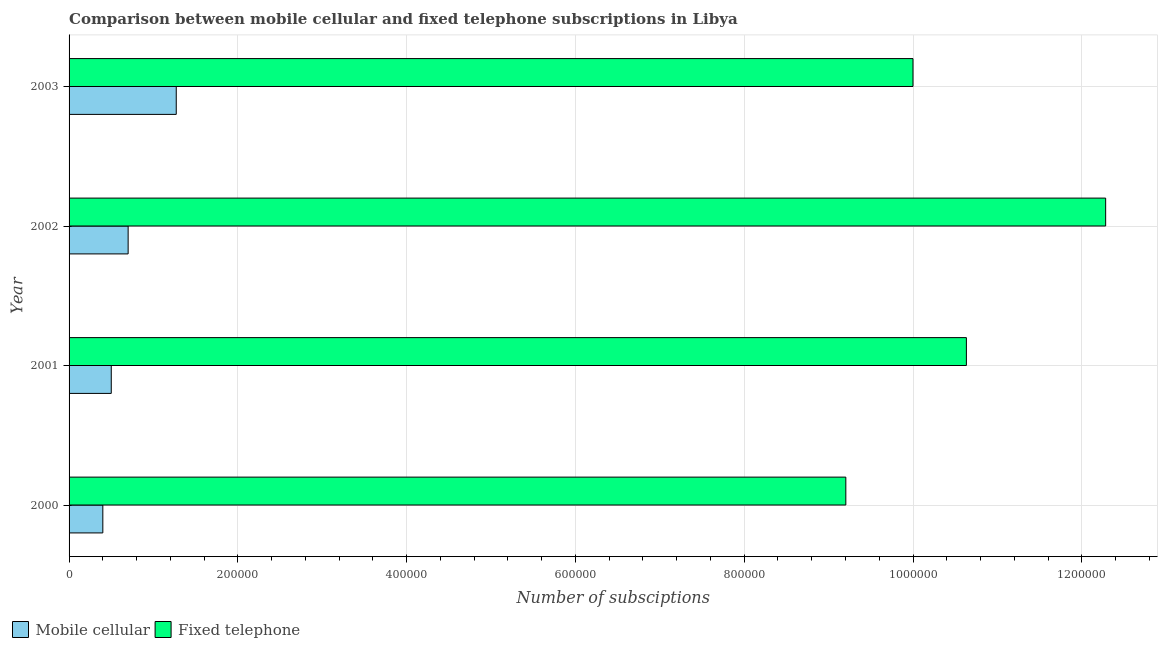How many groups of bars are there?
Keep it short and to the point. 4. Are the number of bars per tick equal to the number of legend labels?
Keep it short and to the point. Yes. In how many cases, is the number of bars for a given year not equal to the number of legend labels?
Offer a very short reply. 0. What is the number of fixed telephone subscriptions in 2001?
Offer a terse response. 1.06e+06. Across all years, what is the maximum number of mobile cellular subscriptions?
Make the answer very short. 1.27e+05. Across all years, what is the minimum number of mobile cellular subscriptions?
Offer a very short reply. 4.00e+04. In which year was the number of fixed telephone subscriptions minimum?
Make the answer very short. 2000. What is the total number of fixed telephone subscriptions in the graph?
Provide a succinct answer. 4.21e+06. What is the difference between the number of mobile cellular subscriptions in 2000 and that in 2001?
Provide a short and direct response. -10000. What is the difference between the number of mobile cellular subscriptions in 2002 and the number of fixed telephone subscriptions in 2003?
Your answer should be very brief. -9.30e+05. What is the average number of fixed telephone subscriptions per year?
Provide a short and direct response. 1.05e+06. In the year 2001, what is the difference between the number of fixed telephone subscriptions and number of mobile cellular subscriptions?
Your answer should be compact. 1.01e+06. What is the ratio of the number of mobile cellular subscriptions in 2000 to that in 2003?
Provide a succinct answer. 0.32. Is the number of mobile cellular subscriptions in 2000 less than that in 2001?
Your answer should be compact. Yes. What is the difference between the highest and the second highest number of mobile cellular subscriptions?
Your answer should be very brief. 5.70e+04. What is the difference between the highest and the lowest number of fixed telephone subscriptions?
Provide a succinct answer. 3.08e+05. What does the 2nd bar from the top in 2002 represents?
Ensure brevity in your answer.  Mobile cellular. What does the 2nd bar from the bottom in 2002 represents?
Give a very brief answer. Fixed telephone. How many bars are there?
Your response must be concise. 8. How many legend labels are there?
Provide a short and direct response. 2. How are the legend labels stacked?
Provide a succinct answer. Horizontal. What is the title of the graph?
Provide a succinct answer. Comparison between mobile cellular and fixed telephone subscriptions in Libya. Does "Working only" appear as one of the legend labels in the graph?
Make the answer very short. No. What is the label or title of the X-axis?
Your answer should be very brief. Number of subsciptions. What is the Number of subsciptions of Mobile cellular in 2000?
Offer a very short reply. 4.00e+04. What is the Number of subsciptions of Fixed telephone in 2000?
Offer a terse response. 9.20e+05. What is the Number of subsciptions in Fixed telephone in 2001?
Provide a short and direct response. 1.06e+06. What is the Number of subsciptions in Fixed telephone in 2002?
Your response must be concise. 1.23e+06. What is the Number of subsciptions in Mobile cellular in 2003?
Make the answer very short. 1.27e+05. Across all years, what is the maximum Number of subsciptions of Mobile cellular?
Give a very brief answer. 1.27e+05. Across all years, what is the maximum Number of subsciptions of Fixed telephone?
Keep it short and to the point. 1.23e+06. Across all years, what is the minimum Number of subsciptions of Mobile cellular?
Provide a succinct answer. 4.00e+04. Across all years, what is the minimum Number of subsciptions in Fixed telephone?
Ensure brevity in your answer.  9.20e+05. What is the total Number of subsciptions of Mobile cellular in the graph?
Your answer should be very brief. 2.87e+05. What is the total Number of subsciptions of Fixed telephone in the graph?
Give a very brief answer. 4.21e+06. What is the difference between the Number of subsciptions of Mobile cellular in 2000 and that in 2001?
Your response must be concise. -10000. What is the difference between the Number of subsciptions of Fixed telephone in 2000 and that in 2001?
Provide a short and direct response. -1.43e+05. What is the difference between the Number of subsciptions of Fixed telephone in 2000 and that in 2002?
Provide a short and direct response. -3.08e+05. What is the difference between the Number of subsciptions of Mobile cellular in 2000 and that in 2003?
Provide a succinct answer. -8.70e+04. What is the difference between the Number of subsciptions in Fixed telephone in 2000 and that in 2003?
Make the answer very short. -7.96e+04. What is the difference between the Number of subsciptions in Fixed telephone in 2001 and that in 2002?
Your answer should be very brief. -1.65e+05. What is the difference between the Number of subsciptions in Mobile cellular in 2001 and that in 2003?
Provide a short and direct response. -7.70e+04. What is the difference between the Number of subsciptions of Fixed telephone in 2001 and that in 2003?
Your response must be concise. 6.33e+04. What is the difference between the Number of subsciptions in Mobile cellular in 2002 and that in 2003?
Your answer should be very brief. -5.70e+04. What is the difference between the Number of subsciptions of Fixed telephone in 2002 and that in 2003?
Make the answer very short. 2.28e+05. What is the difference between the Number of subsciptions of Mobile cellular in 2000 and the Number of subsciptions of Fixed telephone in 2001?
Your answer should be very brief. -1.02e+06. What is the difference between the Number of subsciptions in Mobile cellular in 2000 and the Number of subsciptions in Fixed telephone in 2002?
Ensure brevity in your answer.  -1.19e+06. What is the difference between the Number of subsciptions in Mobile cellular in 2000 and the Number of subsciptions in Fixed telephone in 2003?
Offer a very short reply. -9.60e+05. What is the difference between the Number of subsciptions in Mobile cellular in 2001 and the Number of subsciptions in Fixed telephone in 2002?
Keep it short and to the point. -1.18e+06. What is the difference between the Number of subsciptions of Mobile cellular in 2001 and the Number of subsciptions of Fixed telephone in 2003?
Offer a very short reply. -9.50e+05. What is the difference between the Number of subsciptions in Mobile cellular in 2002 and the Number of subsciptions in Fixed telephone in 2003?
Make the answer very short. -9.30e+05. What is the average Number of subsciptions of Mobile cellular per year?
Give a very brief answer. 7.18e+04. What is the average Number of subsciptions in Fixed telephone per year?
Offer a very short reply. 1.05e+06. In the year 2000, what is the difference between the Number of subsciptions of Mobile cellular and Number of subsciptions of Fixed telephone?
Make the answer very short. -8.80e+05. In the year 2001, what is the difference between the Number of subsciptions in Mobile cellular and Number of subsciptions in Fixed telephone?
Ensure brevity in your answer.  -1.01e+06. In the year 2002, what is the difference between the Number of subsciptions in Mobile cellular and Number of subsciptions in Fixed telephone?
Your response must be concise. -1.16e+06. In the year 2003, what is the difference between the Number of subsciptions in Mobile cellular and Number of subsciptions in Fixed telephone?
Provide a short and direct response. -8.73e+05. What is the ratio of the Number of subsciptions in Fixed telephone in 2000 to that in 2001?
Offer a very short reply. 0.87. What is the ratio of the Number of subsciptions in Mobile cellular in 2000 to that in 2002?
Provide a short and direct response. 0.57. What is the ratio of the Number of subsciptions in Fixed telephone in 2000 to that in 2002?
Provide a succinct answer. 0.75. What is the ratio of the Number of subsciptions of Mobile cellular in 2000 to that in 2003?
Your answer should be compact. 0.32. What is the ratio of the Number of subsciptions of Fixed telephone in 2000 to that in 2003?
Your answer should be compact. 0.92. What is the ratio of the Number of subsciptions of Fixed telephone in 2001 to that in 2002?
Offer a very short reply. 0.87. What is the ratio of the Number of subsciptions in Mobile cellular in 2001 to that in 2003?
Your response must be concise. 0.39. What is the ratio of the Number of subsciptions of Fixed telephone in 2001 to that in 2003?
Provide a succinct answer. 1.06. What is the ratio of the Number of subsciptions of Mobile cellular in 2002 to that in 2003?
Give a very brief answer. 0.55. What is the ratio of the Number of subsciptions in Fixed telephone in 2002 to that in 2003?
Your answer should be very brief. 1.23. What is the difference between the highest and the second highest Number of subsciptions of Mobile cellular?
Make the answer very short. 5.70e+04. What is the difference between the highest and the second highest Number of subsciptions of Fixed telephone?
Your answer should be very brief. 1.65e+05. What is the difference between the highest and the lowest Number of subsciptions in Mobile cellular?
Make the answer very short. 8.70e+04. What is the difference between the highest and the lowest Number of subsciptions of Fixed telephone?
Your answer should be very brief. 3.08e+05. 